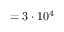Convert formula to latex. <formula><loc_0><loc_0><loc_500><loc_500>= 3 \cdot 1 0 ^ { 4 }</formula> 